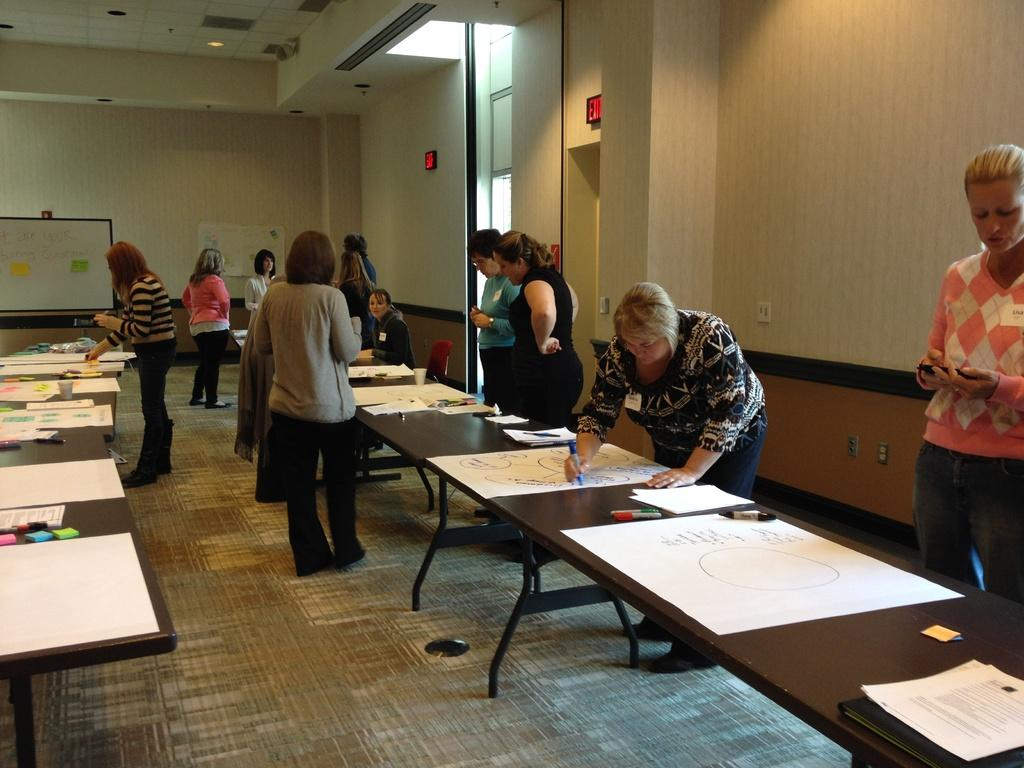What are the persons in the image doing? The persons in the image are drawing on a chart. What is present on the table in the image? There are pens on the table. What can be seen in the background of the image? There is a wall and a board in the background of the image. What type of wealth is depicted on the board in the image? There is no depiction of wealth on the board in the image; it is a background element. What kind of cable can be seen connecting the pens to the persons drawing on the chart? There is no cable connecting the pens to the persons drawing on the chart in the image. 